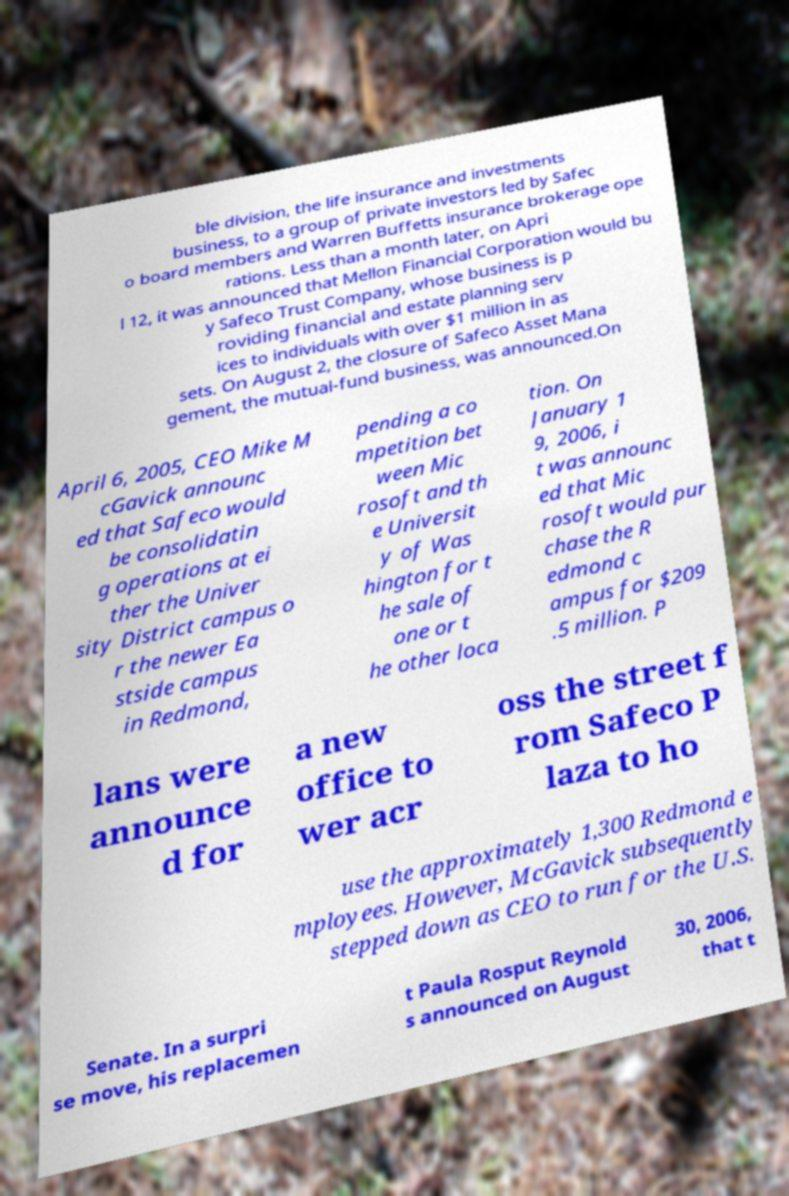Can you accurately transcribe the text from the provided image for me? ble division, the life insurance and investments business, to a group of private investors led by Safec o board members and Warren Buffetts insurance brokerage ope rations. Less than a month later, on Apri l 12, it was announced that Mellon Financial Corporation would bu y Safeco Trust Company, whose business is p roviding financial and estate planning serv ices to individuals with over $1 million in as sets. On August 2, the closure of Safeco Asset Mana gement, the mutual-fund business, was announced.On April 6, 2005, CEO Mike M cGavick announc ed that Safeco would be consolidatin g operations at ei ther the Univer sity District campus o r the newer Ea stside campus in Redmond, pending a co mpetition bet ween Mic rosoft and th e Universit y of Was hington for t he sale of one or t he other loca tion. On January 1 9, 2006, i t was announc ed that Mic rosoft would pur chase the R edmond c ampus for $209 .5 million. P lans were announce d for a new office to wer acr oss the street f rom Safeco P laza to ho use the approximately 1,300 Redmond e mployees. However, McGavick subsequently stepped down as CEO to run for the U.S. Senate. In a surpri se move, his replacemen t Paula Rosput Reynold s announced on August 30, 2006, that t 